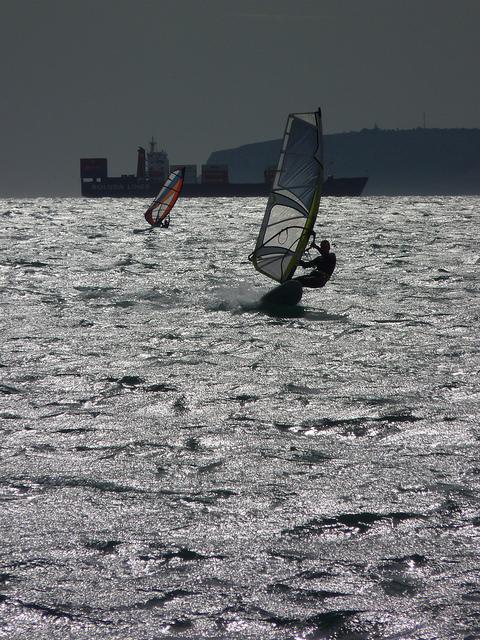What vessel is behind the sail boards?
Answer briefly. Ship. What is the water conditions like?
Short answer required. Rough. What is the man holding?
Short answer required. Sail. Is the water calm?
Short answer required. No. Is there a lighthouse?
Give a very brief answer. No. Is the wind blowing?
Concise answer only. Yes. What is the man doing?
Concise answer only. Windsurfing. What color is the water?
Short answer required. Blue. How deep is the water?
Keep it brief. Very deep. What is the weather like?
Give a very brief answer. Cloudy. Whose foot is in the air?
Write a very short answer. Surfer. 